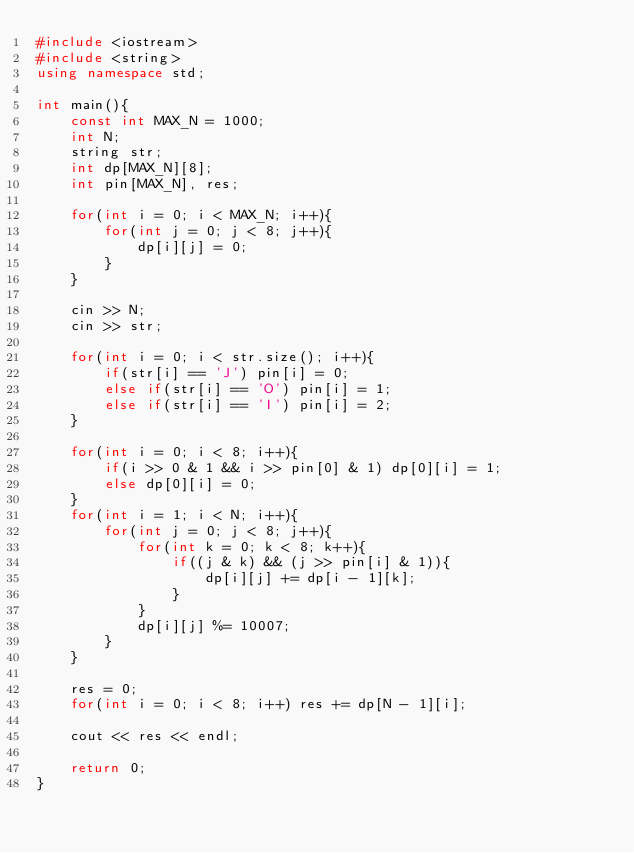Convert code to text. <code><loc_0><loc_0><loc_500><loc_500><_C++_>#include <iostream>
#include <string>
using namespace std;

int main(){
	const int MAX_N = 1000;
	int N;
	string str;
	int dp[MAX_N][8];
	int pin[MAX_N], res;
	
	for(int i = 0; i < MAX_N; i++){
		for(int j = 0; j < 8; j++){
			dp[i][j] = 0;
		}
	}
	
	cin >> N;
	cin >> str;
	
	for(int i = 0; i < str.size(); i++){
		if(str[i] == 'J') pin[i] = 0;
		else if(str[i] == 'O') pin[i] = 1;
		else if(str[i] == 'I') pin[i] = 2;
	}
	
	for(int i = 0; i < 8; i++){
		if(i >> 0 & 1 && i >> pin[0] & 1) dp[0][i] = 1;
		else dp[0][i] = 0;
	}
	for(int i = 1; i < N; i++){
		for(int j = 0; j < 8; j++){
			for(int k = 0; k < 8; k++){
				if((j & k) && (j >> pin[i] & 1)){
					dp[i][j] += dp[i - 1][k];
				}
			}
			dp[i][j] %= 10007;
		}
	}
	
	res = 0;
	for(int i = 0; i < 8; i++) res += dp[N - 1][i];
	
	cout << res << endl;
	
	return 0;
}</code> 